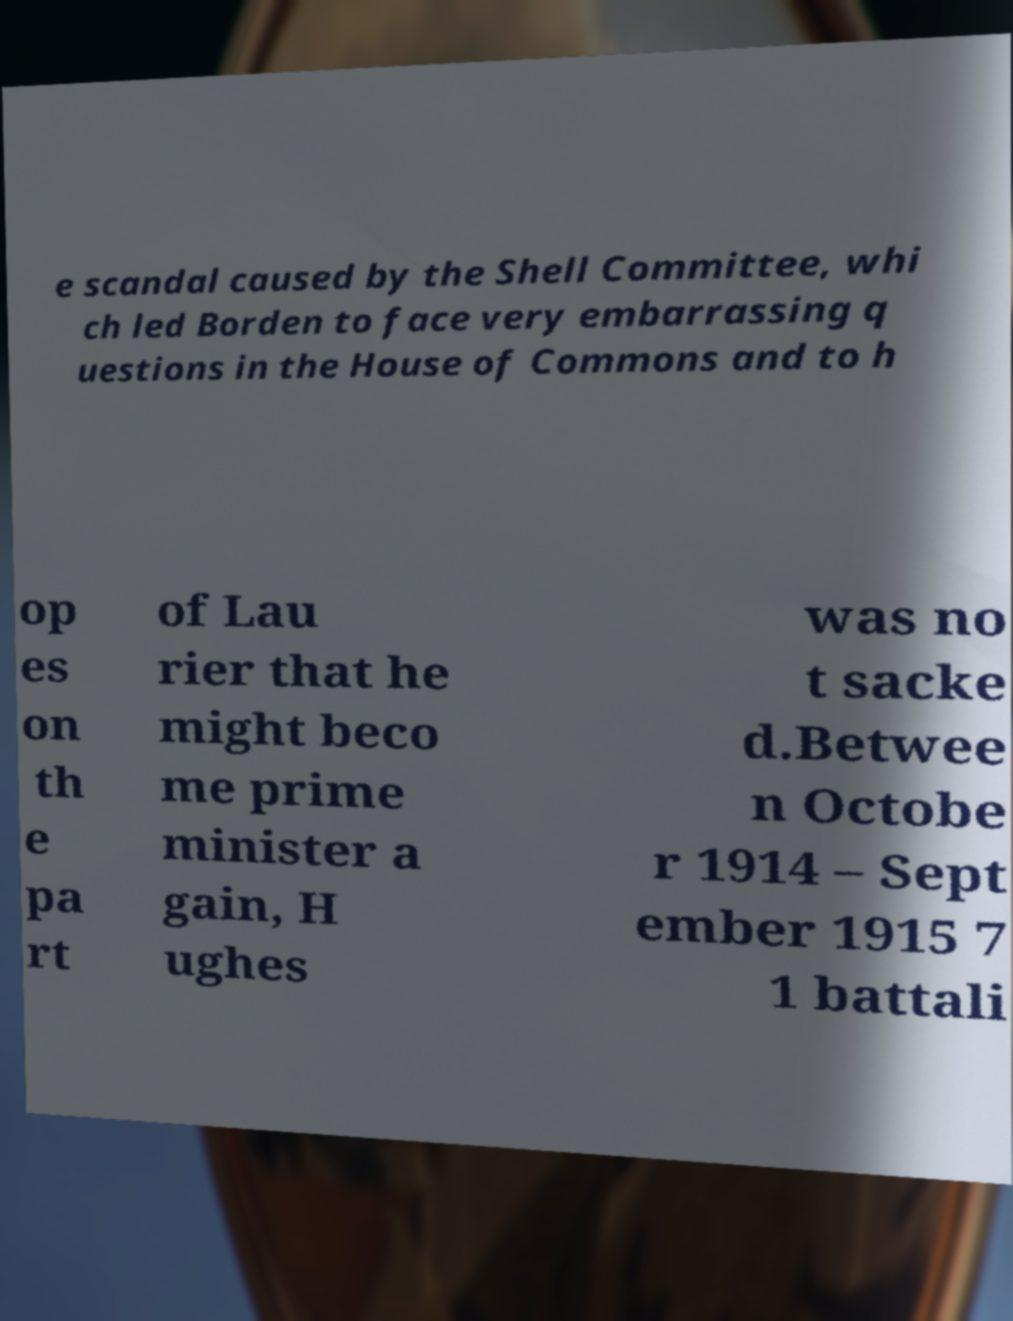Please read and relay the text visible in this image. What does it say? e scandal caused by the Shell Committee, whi ch led Borden to face very embarrassing q uestions in the House of Commons and to h op es on th e pa rt of Lau rier that he might beco me prime minister a gain, H ughes was no t sacke d.Betwee n Octobe r 1914 – Sept ember 1915 7 1 battali 